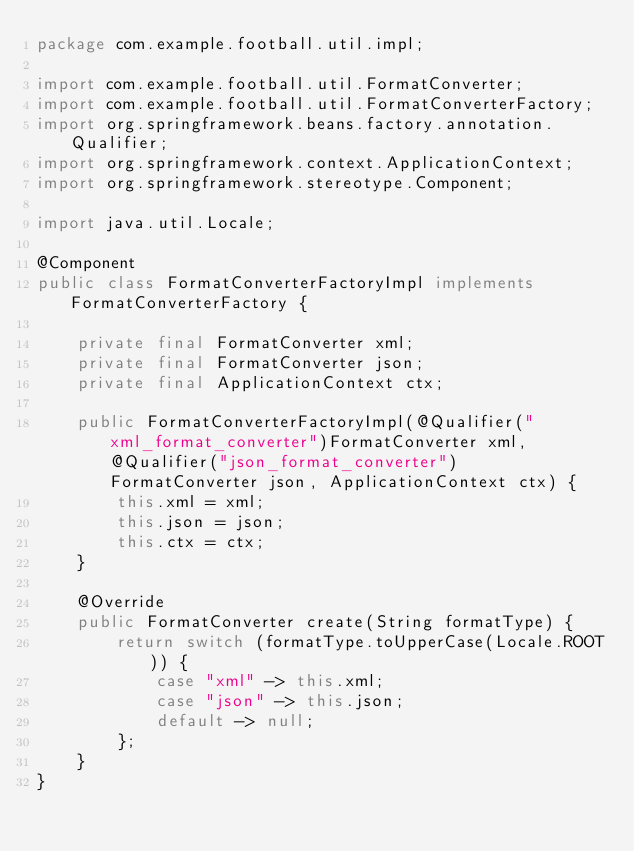<code> <loc_0><loc_0><loc_500><loc_500><_Java_>package com.example.football.util.impl;

import com.example.football.util.FormatConverter;
import com.example.football.util.FormatConverterFactory;
import org.springframework.beans.factory.annotation.Qualifier;
import org.springframework.context.ApplicationContext;
import org.springframework.stereotype.Component;

import java.util.Locale;

@Component
public class FormatConverterFactoryImpl implements FormatConverterFactory {

    private final FormatConverter xml;
    private final FormatConverter json;
    private final ApplicationContext ctx;

    public FormatConverterFactoryImpl(@Qualifier("xml_format_converter")FormatConverter xml, @Qualifier("json_format_converter") FormatConverter json, ApplicationContext ctx) {
        this.xml = xml;
        this.json = json;
        this.ctx = ctx;
    }

    @Override
    public FormatConverter create(String formatType) {
        return switch (formatType.toUpperCase(Locale.ROOT)) {
            case "xml" -> this.xml;
            case "json" -> this.json;
            default -> null;
        };
    }
}
</code> 